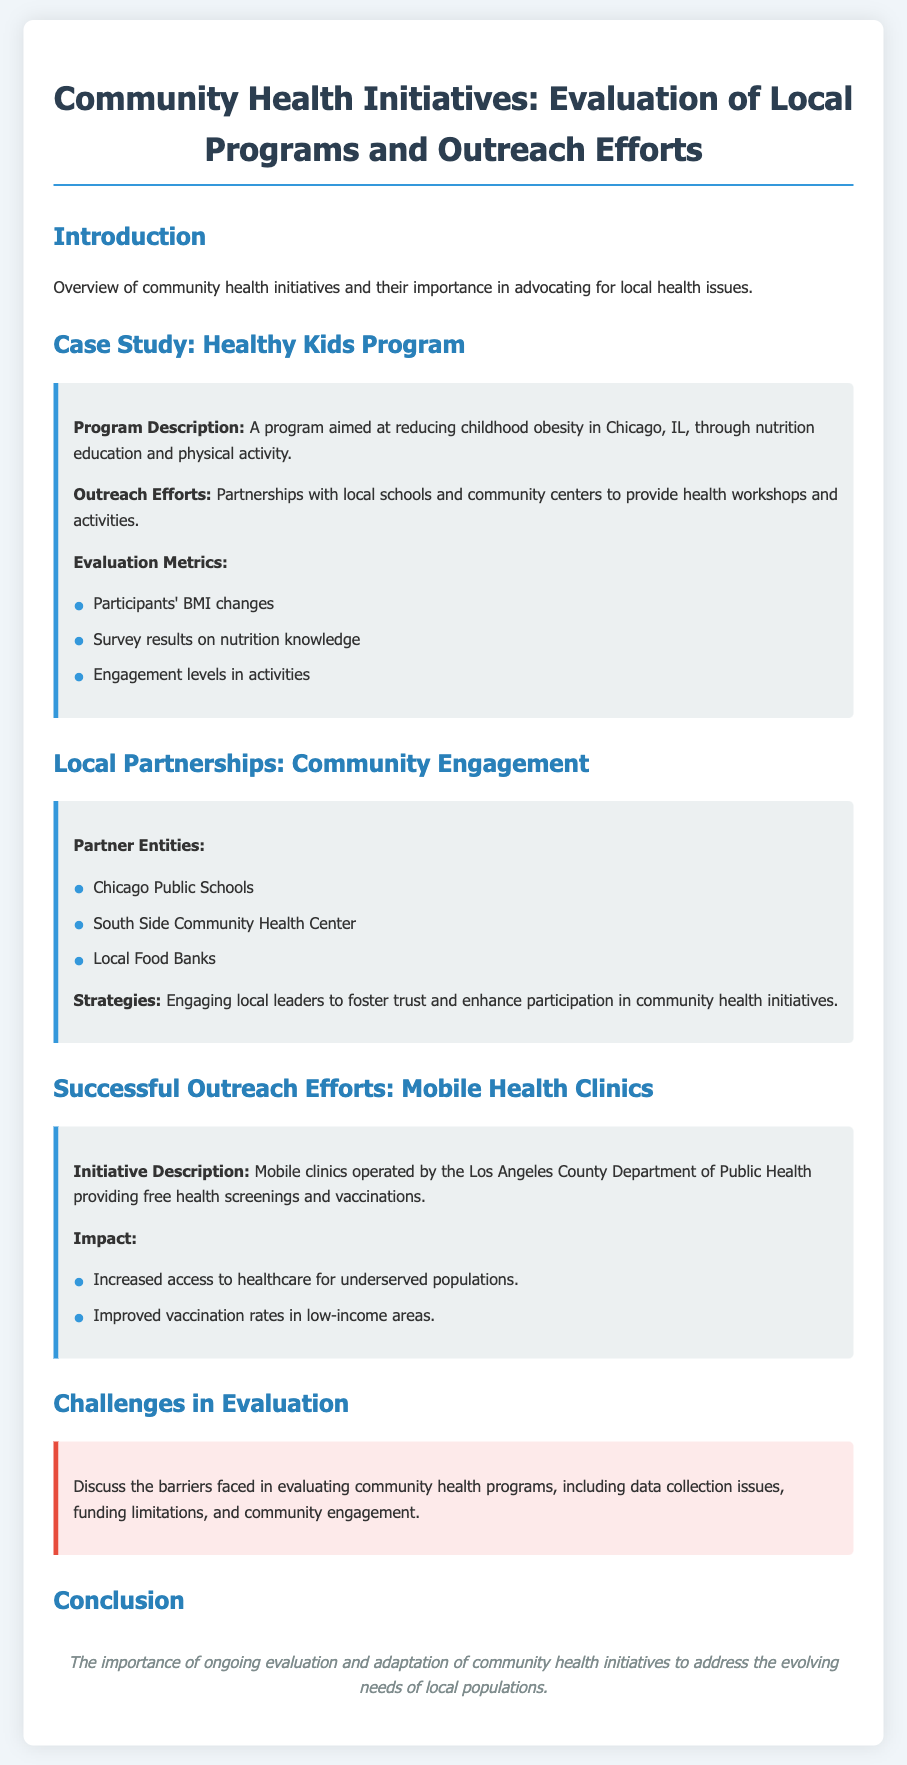What is the program aimed at reducing childhood obesity? The program is described as the Healthy Kids Program, focusing on nutrition education and physical activity.
Answer: Healthy Kids Program Which city is the Healthy Kids Program located in? It is specified in the document that the Healthy Kids Program is in Chicago, IL.
Answer: Chicago, IL What is one of the outreach partners listed? The document lists partner entities including the Chicago Public Schools.
Answer: Chicago Public Schools What is one impact of the mobile health clinics mentioned? The document states that mobile clinics improved vaccination rates in low-income areas.
Answer: Improved vaccination rates What is a barrier faced in evaluating community health programs? The document discusses issues such as data collection as a challenge in evaluation, along with funding limitations and community engagement.
Answer: Data collection issues What strategy is mentioned for engaging local leaders? Engaging local leaders to foster trust and enhance participation is highlighted in the partnerships section.
Answer: Foster trust What type of initiative are the mobile clinics categorized as? The mobile clinics are referred to as an outreach effort in the document.
Answer: Outreach effort What is the significance of evaluating community health initiatives according to the conclusion? The conclusion emphasizes the importance of ongoing evaluation and adaptation to address evolving needs.
Answer: Ongoing evaluation How many evaluation metrics are listed for the Healthy Kids Program? The document lists three evaluation metrics related to the Healthy Kids Program.
Answer: Three 